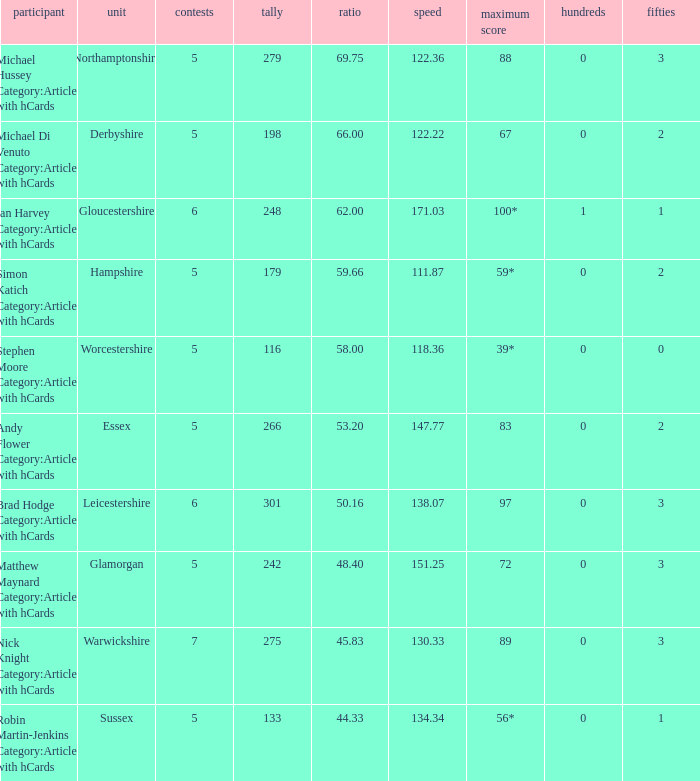If the highest score is 88, what are the 50s? 3.0. 